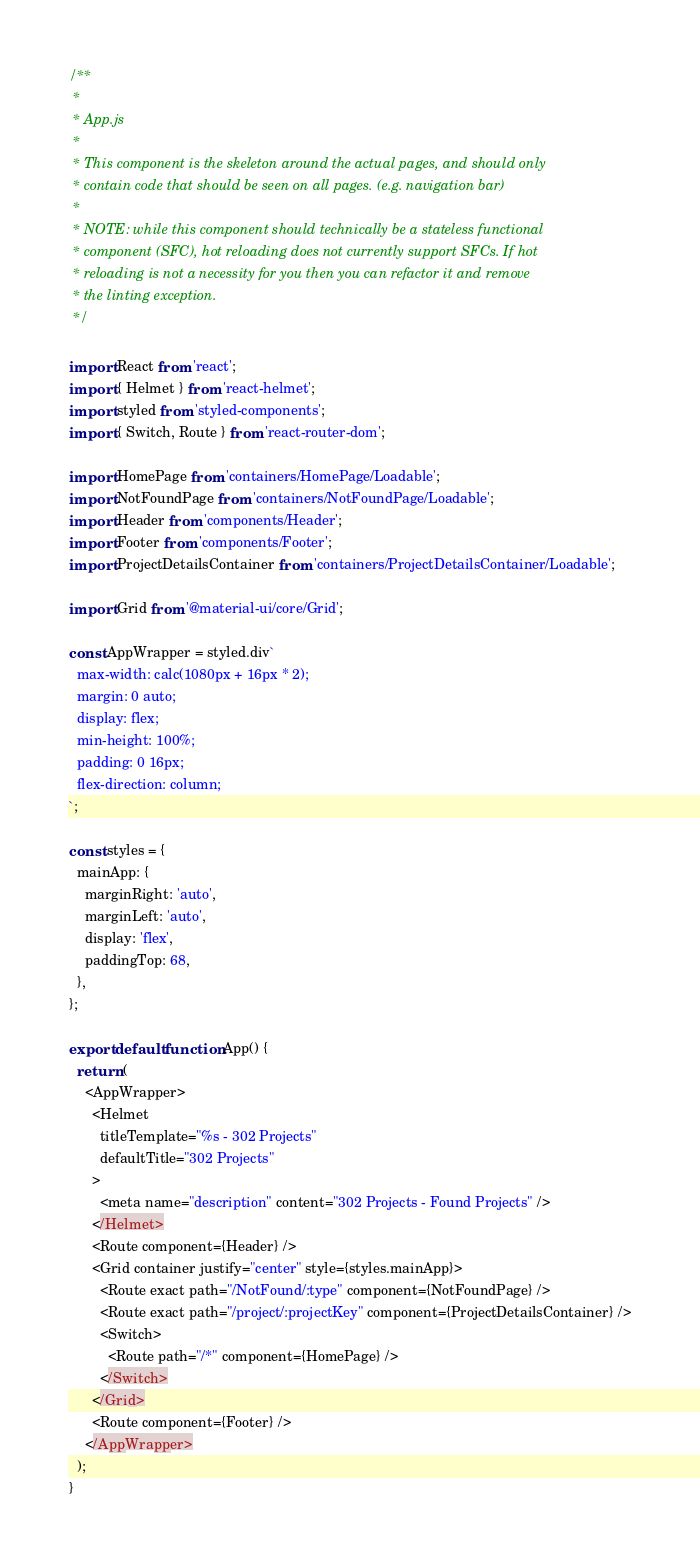Convert code to text. <code><loc_0><loc_0><loc_500><loc_500><_JavaScript_>/**
 *
 * App.js
 *
 * This component is the skeleton around the actual pages, and should only
 * contain code that should be seen on all pages. (e.g. navigation bar)
 *
 * NOTE: while this component should technically be a stateless functional
 * component (SFC), hot reloading does not currently support SFCs. If hot
 * reloading is not a necessity for you then you can refactor it and remove
 * the linting exception.
 */

import React from 'react';
import { Helmet } from 'react-helmet';
import styled from 'styled-components';
import { Switch, Route } from 'react-router-dom';

import HomePage from 'containers/HomePage/Loadable';
import NotFoundPage from 'containers/NotFoundPage/Loadable';
import Header from 'components/Header';
import Footer from 'components/Footer';
import ProjectDetailsContainer from 'containers/ProjectDetailsContainer/Loadable';

import Grid from '@material-ui/core/Grid';

const AppWrapper = styled.div`
  max-width: calc(1080px + 16px * 2);
  margin: 0 auto;
  display: flex;
  min-height: 100%;
  padding: 0 16px;
  flex-direction: column;
`;

const styles = {
  mainApp: {
    marginRight: 'auto',
    marginLeft: 'auto',
    display: 'flex',
    paddingTop: 68,
  },
};

export default function App() {
  return (
    <AppWrapper>
      <Helmet
        titleTemplate="%s - 302 Projects"
        defaultTitle="302 Projects"
      >
        <meta name="description" content="302 Projects - Found Projects" />
      </Helmet>
      <Route component={Header} />
      <Grid container justify="center" style={styles.mainApp}>
        <Route exact path="/NotFound/:type" component={NotFoundPage} />
        <Route exact path="/project/:projectKey" component={ProjectDetailsContainer} />
        <Switch>
          <Route path="/*" component={HomePage} />
        </Switch>
      </Grid>
      <Route component={Footer} />
    </AppWrapper>
  );
}
</code> 